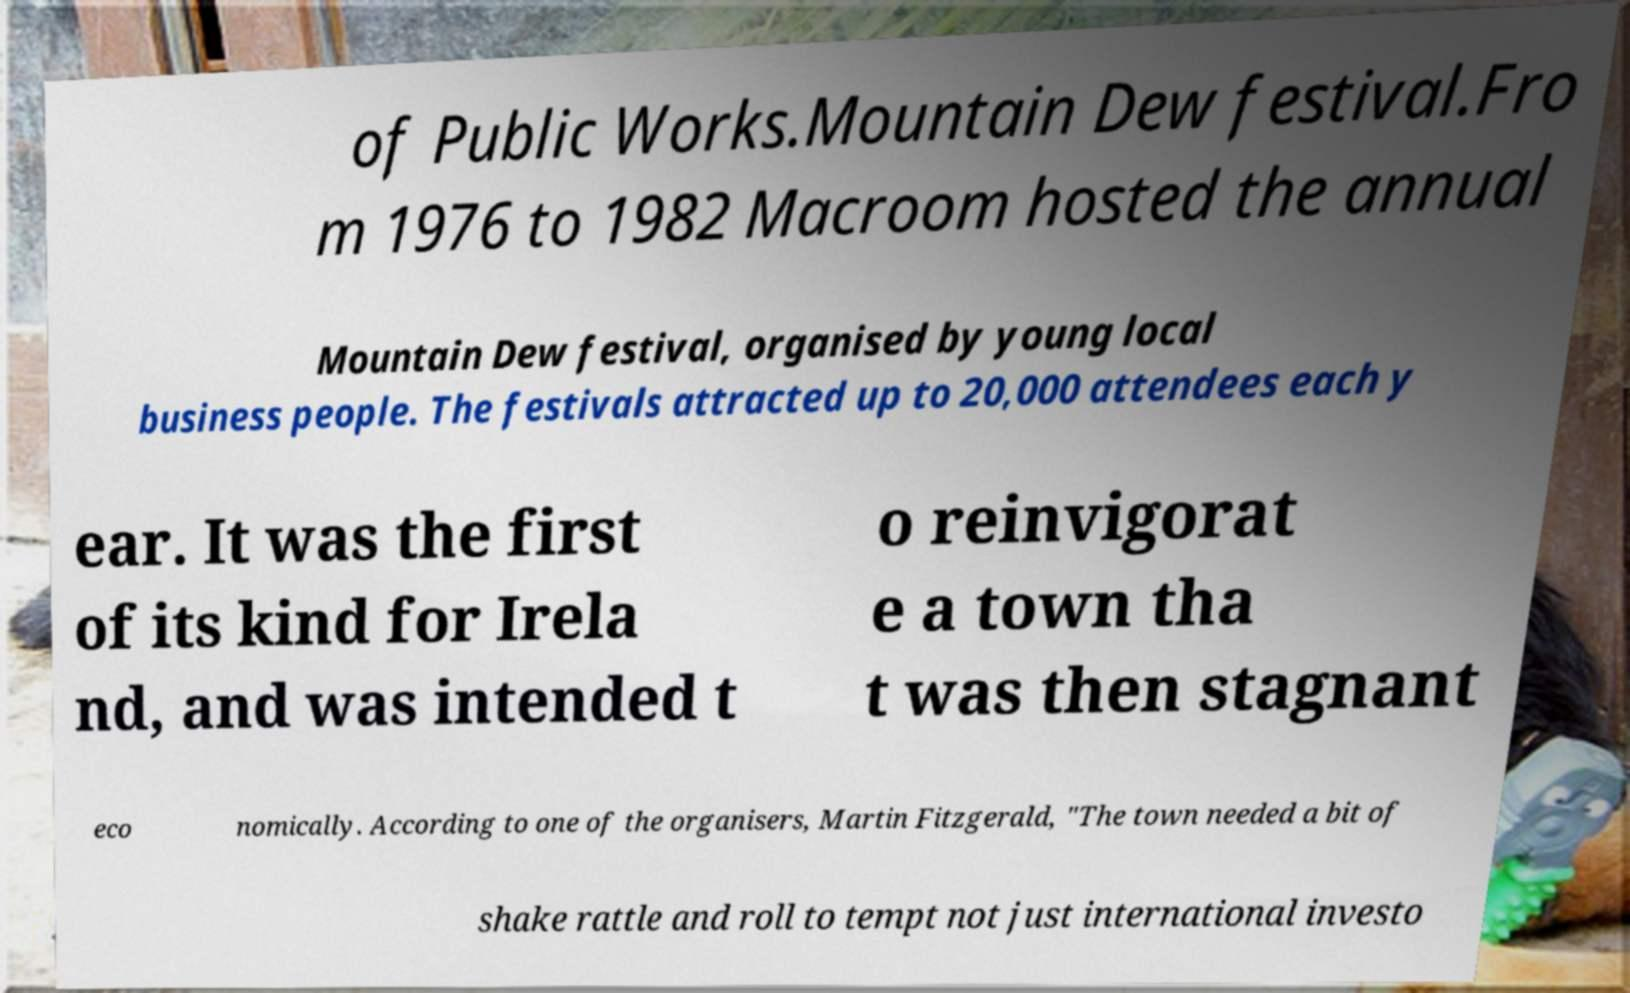Please identify and transcribe the text found in this image. of Public Works.Mountain Dew festival.Fro m 1976 to 1982 Macroom hosted the annual Mountain Dew festival, organised by young local business people. The festivals attracted up to 20,000 attendees each y ear. It was the first of its kind for Irela nd, and was intended t o reinvigorat e a town tha t was then stagnant eco nomically. According to one of the organisers, Martin Fitzgerald, "The town needed a bit of shake rattle and roll to tempt not just international investo 